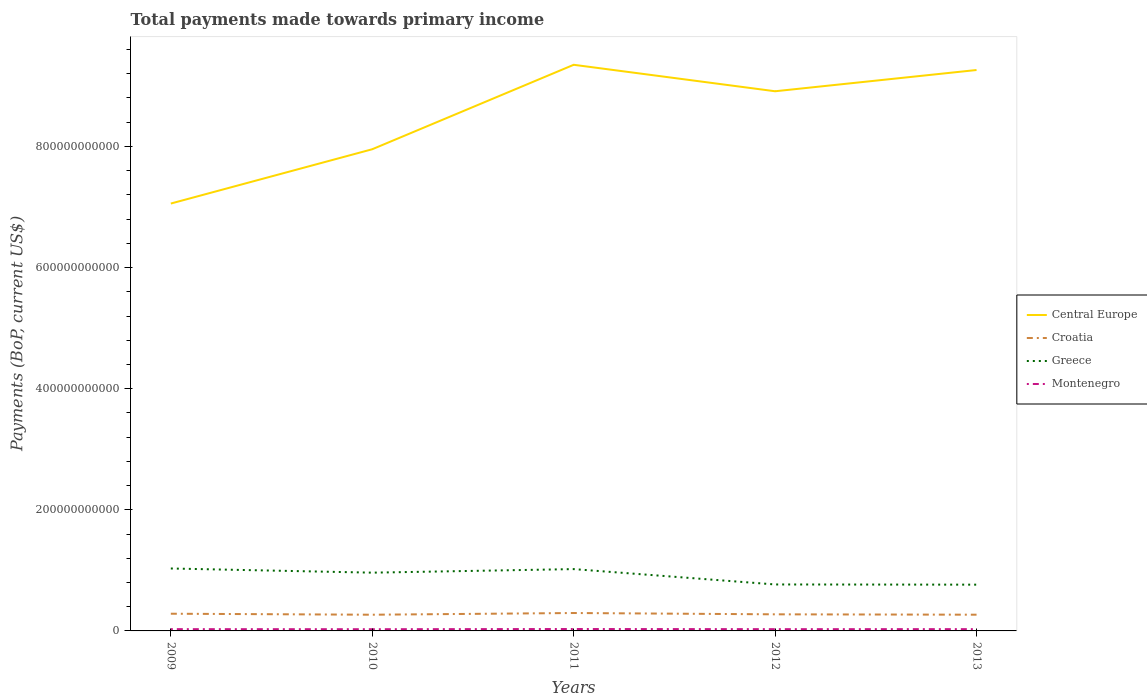How many different coloured lines are there?
Provide a succinct answer. 4. Is the number of lines equal to the number of legend labels?
Offer a very short reply. Yes. Across all years, what is the maximum total payments made towards primary income in Croatia?
Give a very brief answer. 2.67e+1. In which year was the total payments made towards primary income in Greece maximum?
Your answer should be compact. 2013. What is the total total payments made towards primary income in Greece in the graph?
Make the answer very short. 2.67e+1. What is the difference between the highest and the second highest total payments made towards primary income in Croatia?
Provide a succinct answer. 2.82e+09. How many years are there in the graph?
Ensure brevity in your answer.  5. What is the difference between two consecutive major ticks on the Y-axis?
Provide a succinct answer. 2.00e+11. Are the values on the major ticks of Y-axis written in scientific E-notation?
Give a very brief answer. No. Where does the legend appear in the graph?
Keep it short and to the point. Center right. How are the legend labels stacked?
Keep it short and to the point. Vertical. What is the title of the graph?
Your answer should be compact. Total payments made towards primary income. What is the label or title of the X-axis?
Ensure brevity in your answer.  Years. What is the label or title of the Y-axis?
Provide a short and direct response. Payments (BoP, current US$). What is the Payments (BoP, current US$) in Central Europe in 2009?
Provide a short and direct response. 7.06e+11. What is the Payments (BoP, current US$) of Croatia in 2009?
Ensure brevity in your answer.  2.84e+1. What is the Payments (BoP, current US$) in Greece in 2009?
Ensure brevity in your answer.  1.03e+11. What is the Payments (BoP, current US$) in Montenegro in 2009?
Provide a succinct answer. 2.93e+09. What is the Payments (BoP, current US$) of Central Europe in 2010?
Provide a succinct answer. 7.95e+11. What is the Payments (BoP, current US$) of Croatia in 2010?
Offer a terse response. 2.67e+1. What is the Payments (BoP, current US$) of Greece in 2010?
Your response must be concise. 9.62e+1. What is the Payments (BoP, current US$) of Montenegro in 2010?
Offer a terse response. 2.83e+09. What is the Payments (BoP, current US$) in Central Europe in 2011?
Keep it short and to the point. 9.35e+11. What is the Payments (BoP, current US$) in Croatia in 2011?
Offer a terse response. 2.96e+1. What is the Payments (BoP, current US$) of Greece in 2011?
Provide a short and direct response. 1.02e+11. What is the Payments (BoP, current US$) in Montenegro in 2011?
Provide a succinct answer. 3.15e+09. What is the Payments (BoP, current US$) of Central Europe in 2012?
Give a very brief answer. 8.91e+11. What is the Payments (BoP, current US$) in Croatia in 2012?
Your answer should be very brief. 2.74e+1. What is the Payments (BoP, current US$) in Greece in 2012?
Provide a succinct answer. 7.67e+1. What is the Payments (BoP, current US$) in Montenegro in 2012?
Your response must be concise. 2.92e+09. What is the Payments (BoP, current US$) of Central Europe in 2013?
Ensure brevity in your answer.  9.26e+11. What is the Payments (BoP, current US$) of Croatia in 2013?
Your answer should be compact. 2.68e+1. What is the Payments (BoP, current US$) of Greece in 2013?
Provide a succinct answer. 7.64e+1. What is the Payments (BoP, current US$) of Montenegro in 2013?
Keep it short and to the point. 2.94e+09. Across all years, what is the maximum Payments (BoP, current US$) of Central Europe?
Provide a succinct answer. 9.35e+11. Across all years, what is the maximum Payments (BoP, current US$) in Croatia?
Give a very brief answer. 2.96e+1. Across all years, what is the maximum Payments (BoP, current US$) of Greece?
Keep it short and to the point. 1.03e+11. Across all years, what is the maximum Payments (BoP, current US$) of Montenegro?
Keep it short and to the point. 3.15e+09. Across all years, what is the minimum Payments (BoP, current US$) in Central Europe?
Offer a very short reply. 7.06e+11. Across all years, what is the minimum Payments (BoP, current US$) of Croatia?
Offer a very short reply. 2.67e+1. Across all years, what is the minimum Payments (BoP, current US$) of Greece?
Your response must be concise. 7.64e+1. Across all years, what is the minimum Payments (BoP, current US$) of Montenegro?
Provide a short and direct response. 2.83e+09. What is the total Payments (BoP, current US$) of Central Europe in the graph?
Provide a short and direct response. 4.25e+12. What is the total Payments (BoP, current US$) of Croatia in the graph?
Your answer should be compact. 1.39e+11. What is the total Payments (BoP, current US$) of Greece in the graph?
Your answer should be very brief. 4.54e+11. What is the total Payments (BoP, current US$) in Montenegro in the graph?
Keep it short and to the point. 1.48e+1. What is the difference between the Payments (BoP, current US$) in Central Europe in 2009 and that in 2010?
Your answer should be very brief. -8.97e+1. What is the difference between the Payments (BoP, current US$) of Croatia in 2009 and that in 2010?
Your response must be concise. 1.66e+09. What is the difference between the Payments (BoP, current US$) of Greece in 2009 and that in 2010?
Give a very brief answer. 6.88e+09. What is the difference between the Payments (BoP, current US$) in Montenegro in 2009 and that in 2010?
Offer a terse response. 1.07e+08. What is the difference between the Payments (BoP, current US$) in Central Europe in 2009 and that in 2011?
Offer a terse response. -2.29e+11. What is the difference between the Payments (BoP, current US$) in Croatia in 2009 and that in 2011?
Your response must be concise. -1.16e+09. What is the difference between the Payments (BoP, current US$) of Greece in 2009 and that in 2011?
Your answer should be very brief. 1.01e+09. What is the difference between the Payments (BoP, current US$) of Montenegro in 2009 and that in 2011?
Your answer should be very brief. -2.19e+08. What is the difference between the Payments (BoP, current US$) in Central Europe in 2009 and that in 2012?
Your response must be concise. -1.85e+11. What is the difference between the Payments (BoP, current US$) of Croatia in 2009 and that in 2012?
Your answer should be compact. 1.01e+09. What is the difference between the Payments (BoP, current US$) of Greece in 2009 and that in 2012?
Provide a short and direct response. 2.64e+1. What is the difference between the Payments (BoP, current US$) of Montenegro in 2009 and that in 2012?
Your answer should be compact. 1.51e+07. What is the difference between the Payments (BoP, current US$) in Central Europe in 2009 and that in 2013?
Your response must be concise. -2.20e+11. What is the difference between the Payments (BoP, current US$) in Croatia in 2009 and that in 2013?
Provide a short and direct response. 1.62e+09. What is the difference between the Payments (BoP, current US$) of Greece in 2009 and that in 2013?
Your answer should be very brief. 2.67e+1. What is the difference between the Payments (BoP, current US$) of Montenegro in 2009 and that in 2013?
Give a very brief answer. -4.58e+06. What is the difference between the Payments (BoP, current US$) in Central Europe in 2010 and that in 2011?
Keep it short and to the point. -1.39e+11. What is the difference between the Payments (BoP, current US$) of Croatia in 2010 and that in 2011?
Offer a very short reply. -2.82e+09. What is the difference between the Payments (BoP, current US$) of Greece in 2010 and that in 2011?
Offer a terse response. -5.87e+09. What is the difference between the Payments (BoP, current US$) in Montenegro in 2010 and that in 2011?
Make the answer very short. -3.26e+08. What is the difference between the Payments (BoP, current US$) of Central Europe in 2010 and that in 2012?
Your answer should be compact. -9.57e+1. What is the difference between the Payments (BoP, current US$) in Croatia in 2010 and that in 2012?
Make the answer very short. -6.53e+08. What is the difference between the Payments (BoP, current US$) of Greece in 2010 and that in 2012?
Ensure brevity in your answer.  1.95e+1. What is the difference between the Payments (BoP, current US$) in Montenegro in 2010 and that in 2012?
Ensure brevity in your answer.  -9.16e+07. What is the difference between the Payments (BoP, current US$) of Central Europe in 2010 and that in 2013?
Provide a short and direct response. -1.31e+11. What is the difference between the Payments (BoP, current US$) of Croatia in 2010 and that in 2013?
Make the answer very short. -4.69e+07. What is the difference between the Payments (BoP, current US$) in Greece in 2010 and that in 2013?
Provide a short and direct response. 1.98e+1. What is the difference between the Payments (BoP, current US$) in Montenegro in 2010 and that in 2013?
Keep it short and to the point. -1.11e+08. What is the difference between the Payments (BoP, current US$) in Central Europe in 2011 and that in 2012?
Make the answer very short. 4.37e+1. What is the difference between the Payments (BoP, current US$) of Croatia in 2011 and that in 2012?
Your answer should be compact. 2.17e+09. What is the difference between the Payments (BoP, current US$) of Greece in 2011 and that in 2012?
Give a very brief answer. 2.54e+1. What is the difference between the Payments (BoP, current US$) in Montenegro in 2011 and that in 2012?
Your answer should be compact. 2.34e+08. What is the difference between the Payments (BoP, current US$) in Central Europe in 2011 and that in 2013?
Make the answer very short. 8.61e+09. What is the difference between the Payments (BoP, current US$) in Croatia in 2011 and that in 2013?
Offer a very short reply. 2.77e+09. What is the difference between the Payments (BoP, current US$) of Greece in 2011 and that in 2013?
Provide a short and direct response. 2.57e+1. What is the difference between the Payments (BoP, current US$) of Montenegro in 2011 and that in 2013?
Provide a short and direct response. 2.14e+08. What is the difference between the Payments (BoP, current US$) of Central Europe in 2012 and that in 2013?
Make the answer very short. -3.51e+1. What is the difference between the Payments (BoP, current US$) in Croatia in 2012 and that in 2013?
Offer a terse response. 6.06e+08. What is the difference between the Payments (BoP, current US$) in Greece in 2012 and that in 2013?
Offer a terse response. 3.26e+08. What is the difference between the Payments (BoP, current US$) in Montenegro in 2012 and that in 2013?
Your answer should be compact. -1.97e+07. What is the difference between the Payments (BoP, current US$) of Central Europe in 2009 and the Payments (BoP, current US$) of Croatia in 2010?
Offer a terse response. 6.79e+11. What is the difference between the Payments (BoP, current US$) of Central Europe in 2009 and the Payments (BoP, current US$) of Greece in 2010?
Your answer should be very brief. 6.10e+11. What is the difference between the Payments (BoP, current US$) of Central Europe in 2009 and the Payments (BoP, current US$) of Montenegro in 2010?
Provide a succinct answer. 7.03e+11. What is the difference between the Payments (BoP, current US$) of Croatia in 2009 and the Payments (BoP, current US$) of Greece in 2010?
Keep it short and to the point. -6.78e+1. What is the difference between the Payments (BoP, current US$) of Croatia in 2009 and the Payments (BoP, current US$) of Montenegro in 2010?
Your answer should be compact. 2.56e+1. What is the difference between the Payments (BoP, current US$) in Greece in 2009 and the Payments (BoP, current US$) in Montenegro in 2010?
Make the answer very short. 1.00e+11. What is the difference between the Payments (BoP, current US$) in Central Europe in 2009 and the Payments (BoP, current US$) in Croatia in 2011?
Provide a short and direct response. 6.76e+11. What is the difference between the Payments (BoP, current US$) of Central Europe in 2009 and the Payments (BoP, current US$) of Greece in 2011?
Make the answer very short. 6.04e+11. What is the difference between the Payments (BoP, current US$) in Central Europe in 2009 and the Payments (BoP, current US$) in Montenegro in 2011?
Offer a terse response. 7.03e+11. What is the difference between the Payments (BoP, current US$) of Croatia in 2009 and the Payments (BoP, current US$) of Greece in 2011?
Keep it short and to the point. -7.37e+1. What is the difference between the Payments (BoP, current US$) of Croatia in 2009 and the Payments (BoP, current US$) of Montenegro in 2011?
Your answer should be compact. 2.53e+1. What is the difference between the Payments (BoP, current US$) of Greece in 2009 and the Payments (BoP, current US$) of Montenegro in 2011?
Offer a very short reply. 9.99e+1. What is the difference between the Payments (BoP, current US$) in Central Europe in 2009 and the Payments (BoP, current US$) in Croatia in 2012?
Your answer should be compact. 6.78e+11. What is the difference between the Payments (BoP, current US$) in Central Europe in 2009 and the Payments (BoP, current US$) in Greece in 2012?
Give a very brief answer. 6.29e+11. What is the difference between the Payments (BoP, current US$) in Central Europe in 2009 and the Payments (BoP, current US$) in Montenegro in 2012?
Your response must be concise. 7.03e+11. What is the difference between the Payments (BoP, current US$) of Croatia in 2009 and the Payments (BoP, current US$) of Greece in 2012?
Keep it short and to the point. -4.83e+1. What is the difference between the Payments (BoP, current US$) in Croatia in 2009 and the Payments (BoP, current US$) in Montenegro in 2012?
Make the answer very short. 2.55e+1. What is the difference between the Payments (BoP, current US$) of Greece in 2009 and the Payments (BoP, current US$) of Montenegro in 2012?
Make the answer very short. 1.00e+11. What is the difference between the Payments (BoP, current US$) in Central Europe in 2009 and the Payments (BoP, current US$) in Croatia in 2013?
Offer a very short reply. 6.79e+11. What is the difference between the Payments (BoP, current US$) of Central Europe in 2009 and the Payments (BoP, current US$) of Greece in 2013?
Ensure brevity in your answer.  6.29e+11. What is the difference between the Payments (BoP, current US$) in Central Europe in 2009 and the Payments (BoP, current US$) in Montenegro in 2013?
Offer a terse response. 7.03e+11. What is the difference between the Payments (BoP, current US$) in Croatia in 2009 and the Payments (BoP, current US$) in Greece in 2013?
Keep it short and to the point. -4.80e+1. What is the difference between the Payments (BoP, current US$) of Croatia in 2009 and the Payments (BoP, current US$) of Montenegro in 2013?
Ensure brevity in your answer.  2.55e+1. What is the difference between the Payments (BoP, current US$) in Greece in 2009 and the Payments (BoP, current US$) in Montenegro in 2013?
Give a very brief answer. 1.00e+11. What is the difference between the Payments (BoP, current US$) in Central Europe in 2010 and the Payments (BoP, current US$) in Croatia in 2011?
Your response must be concise. 7.66e+11. What is the difference between the Payments (BoP, current US$) in Central Europe in 2010 and the Payments (BoP, current US$) in Greece in 2011?
Offer a terse response. 6.93e+11. What is the difference between the Payments (BoP, current US$) of Central Europe in 2010 and the Payments (BoP, current US$) of Montenegro in 2011?
Ensure brevity in your answer.  7.92e+11. What is the difference between the Payments (BoP, current US$) in Croatia in 2010 and the Payments (BoP, current US$) in Greece in 2011?
Give a very brief answer. -7.53e+1. What is the difference between the Payments (BoP, current US$) in Croatia in 2010 and the Payments (BoP, current US$) in Montenegro in 2011?
Ensure brevity in your answer.  2.36e+1. What is the difference between the Payments (BoP, current US$) of Greece in 2010 and the Payments (BoP, current US$) of Montenegro in 2011?
Offer a terse response. 9.31e+1. What is the difference between the Payments (BoP, current US$) in Central Europe in 2010 and the Payments (BoP, current US$) in Croatia in 2012?
Offer a very short reply. 7.68e+11. What is the difference between the Payments (BoP, current US$) of Central Europe in 2010 and the Payments (BoP, current US$) of Greece in 2012?
Give a very brief answer. 7.19e+11. What is the difference between the Payments (BoP, current US$) of Central Europe in 2010 and the Payments (BoP, current US$) of Montenegro in 2012?
Offer a very short reply. 7.92e+11. What is the difference between the Payments (BoP, current US$) of Croatia in 2010 and the Payments (BoP, current US$) of Greece in 2012?
Keep it short and to the point. -5.00e+1. What is the difference between the Payments (BoP, current US$) of Croatia in 2010 and the Payments (BoP, current US$) of Montenegro in 2012?
Your answer should be very brief. 2.38e+1. What is the difference between the Payments (BoP, current US$) of Greece in 2010 and the Payments (BoP, current US$) of Montenegro in 2012?
Your response must be concise. 9.33e+1. What is the difference between the Payments (BoP, current US$) in Central Europe in 2010 and the Payments (BoP, current US$) in Croatia in 2013?
Your answer should be compact. 7.69e+11. What is the difference between the Payments (BoP, current US$) of Central Europe in 2010 and the Payments (BoP, current US$) of Greece in 2013?
Keep it short and to the point. 7.19e+11. What is the difference between the Payments (BoP, current US$) of Central Europe in 2010 and the Payments (BoP, current US$) of Montenegro in 2013?
Your response must be concise. 7.92e+11. What is the difference between the Payments (BoP, current US$) of Croatia in 2010 and the Payments (BoP, current US$) of Greece in 2013?
Your answer should be very brief. -4.96e+1. What is the difference between the Payments (BoP, current US$) of Croatia in 2010 and the Payments (BoP, current US$) of Montenegro in 2013?
Your answer should be very brief. 2.38e+1. What is the difference between the Payments (BoP, current US$) of Greece in 2010 and the Payments (BoP, current US$) of Montenegro in 2013?
Your answer should be very brief. 9.33e+1. What is the difference between the Payments (BoP, current US$) in Central Europe in 2011 and the Payments (BoP, current US$) in Croatia in 2012?
Your response must be concise. 9.07e+11. What is the difference between the Payments (BoP, current US$) of Central Europe in 2011 and the Payments (BoP, current US$) of Greece in 2012?
Keep it short and to the point. 8.58e+11. What is the difference between the Payments (BoP, current US$) in Central Europe in 2011 and the Payments (BoP, current US$) in Montenegro in 2012?
Ensure brevity in your answer.  9.32e+11. What is the difference between the Payments (BoP, current US$) in Croatia in 2011 and the Payments (BoP, current US$) in Greece in 2012?
Offer a very short reply. -4.71e+1. What is the difference between the Payments (BoP, current US$) of Croatia in 2011 and the Payments (BoP, current US$) of Montenegro in 2012?
Provide a short and direct response. 2.67e+1. What is the difference between the Payments (BoP, current US$) of Greece in 2011 and the Payments (BoP, current US$) of Montenegro in 2012?
Offer a very short reply. 9.92e+1. What is the difference between the Payments (BoP, current US$) in Central Europe in 2011 and the Payments (BoP, current US$) in Croatia in 2013?
Provide a succinct answer. 9.08e+11. What is the difference between the Payments (BoP, current US$) of Central Europe in 2011 and the Payments (BoP, current US$) of Greece in 2013?
Provide a succinct answer. 8.58e+11. What is the difference between the Payments (BoP, current US$) in Central Europe in 2011 and the Payments (BoP, current US$) in Montenegro in 2013?
Your response must be concise. 9.32e+11. What is the difference between the Payments (BoP, current US$) in Croatia in 2011 and the Payments (BoP, current US$) in Greece in 2013?
Your answer should be compact. -4.68e+1. What is the difference between the Payments (BoP, current US$) of Croatia in 2011 and the Payments (BoP, current US$) of Montenegro in 2013?
Give a very brief answer. 2.66e+1. What is the difference between the Payments (BoP, current US$) of Greece in 2011 and the Payments (BoP, current US$) of Montenegro in 2013?
Your answer should be very brief. 9.91e+1. What is the difference between the Payments (BoP, current US$) of Central Europe in 2012 and the Payments (BoP, current US$) of Croatia in 2013?
Your answer should be compact. 8.64e+11. What is the difference between the Payments (BoP, current US$) of Central Europe in 2012 and the Payments (BoP, current US$) of Greece in 2013?
Offer a terse response. 8.15e+11. What is the difference between the Payments (BoP, current US$) in Central Europe in 2012 and the Payments (BoP, current US$) in Montenegro in 2013?
Offer a terse response. 8.88e+11. What is the difference between the Payments (BoP, current US$) of Croatia in 2012 and the Payments (BoP, current US$) of Greece in 2013?
Ensure brevity in your answer.  -4.90e+1. What is the difference between the Payments (BoP, current US$) in Croatia in 2012 and the Payments (BoP, current US$) in Montenegro in 2013?
Provide a short and direct response. 2.45e+1. What is the difference between the Payments (BoP, current US$) of Greece in 2012 and the Payments (BoP, current US$) of Montenegro in 2013?
Provide a short and direct response. 7.38e+1. What is the average Payments (BoP, current US$) of Central Europe per year?
Your response must be concise. 8.51e+11. What is the average Payments (BoP, current US$) in Croatia per year?
Give a very brief answer. 2.78e+1. What is the average Payments (BoP, current US$) of Greece per year?
Your response must be concise. 9.09e+1. What is the average Payments (BoP, current US$) of Montenegro per year?
Give a very brief answer. 2.95e+09. In the year 2009, what is the difference between the Payments (BoP, current US$) in Central Europe and Payments (BoP, current US$) in Croatia?
Offer a very short reply. 6.77e+11. In the year 2009, what is the difference between the Payments (BoP, current US$) in Central Europe and Payments (BoP, current US$) in Greece?
Your response must be concise. 6.03e+11. In the year 2009, what is the difference between the Payments (BoP, current US$) in Central Europe and Payments (BoP, current US$) in Montenegro?
Give a very brief answer. 7.03e+11. In the year 2009, what is the difference between the Payments (BoP, current US$) in Croatia and Payments (BoP, current US$) in Greece?
Offer a terse response. -7.47e+1. In the year 2009, what is the difference between the Payments (BoP, current US$) in Croatia and Payments (BoP, current US$) in Montenegro?
Offer a very short reply. 2.55e+1. In the year 2009, what is the difference between the Payments (BoP, current US$) of Greece and Payments (BoP, current US$) of Montenegro?
Give a very brief answer. 1.00e+11. In the year 2010, what is the difference between the Payments (BoP, current US$) of Central Europe and Payments (BoP, current US$) of Croatia?
Your answer should be very brief. 7.69e+11. In the year 2010, what is the difference between the Payments (BoP, current US$) of Central Europe and Payments (BoP, current US$) of Greece?
Keep it short and to the point. 6.99e+11. In the year 2010, what is the difference between the Payments (BoP, current US$) in Central Europe and Payments (BoP, current US$) in Montenegro?
Your answer should be very brief. 7.93e+11. In the year 2010, what is the difference between the Payments (BoP, current US$) of Croatia and Payments (BoP, current US$) of Greece?
Offer a very short reply. -6.95e+1. In the year 2010, what is the difference between the Payments (BoP, current US$) in Croatia and Payments (BoP, current US$) in Montenegro?
Offer a terse response. 2.39e+1. In the year 2010, what is the difference between the Payments (BoP, current US$) of Greece and Payments (BoP, current US$) of Montenegro?
Offer a terse response. 9.34e+1. In the year 2011, what is the difference between the Payments (BoP, current US$) of Central Europe and Payments (BoP, current US$) of Croatia?
Your response must be concise. 9.05e+11. In the year 2011, what is the difference between the Payments (BoP, current US$) in Central Europe and Payments (BoP, current US$) in Greece?
Give a very brief answer. 8.33e+11. In the year 2011, what is the difference between the Payments (BoP, current US$) of Central Europe and Payments (BoP, current US$) of Montenegro?
Your answer should be compact. 9.32e+11. In the year 2011, what is the difference between the Payments (BoP, current US$) of Croatia and Payments (BoP, current US$) of Greece?
Your response must be concise. -7.25e+1. In the year 2011, what is the difference between the Payments (BoP, current US$) of Croatia and Payments (BoP, current US$) of Montenegro?
Offer a very short reply. 2.64e+1. In the year 2011, what is the difference between the Payments (BoP, current US$) of Greece and Payments (BoP, current US$) of Montenegro?
Your answer should be compact. 9.89e+1. In the year 2012, what is the difference between the Payments (BoP, current US$) in Central Europe and Payments (BoP, current US$) in Croatia?
Make the answer very short. 8.64e+11. In the year 2012, what is the difference between the Payments (BoP, current US$) in Central Europe and Payments (BoP, current US$) in Greece?
Keep it short and to the point. 8.14e+11. In the year 2012, what is the difference between the Payments (BoP, current US$) in Central Europe and Payments (BoP, current US$) in Montenegro?
Offer a terse response. 8.88e+11. In the year 2012, what is the difference between the Payments (BoP, current US$) in Croatia and Payments (BoP, current US$) in Greece?
Your response must be concise. -4.93e+1. In the year 2012, what is the difference between the Payments (BoP, current US$) of Croatia and Payments (BoP, current US$) of Montenegro?
Your response must be concise. 2.45e+1. In the year 2012, what is the difference between the Payments (BoP, current US$) in Greece and Payments (BoP, current US$) in Montenegro?
Provide a short and direct response. 7.38e+1. In the year 2013, what is the difference between the Payments (BoP, current US$) in Central Europe and Payments (BoP, current US$) in Croatia?
Keep it short and to the point. 8.99e+11. In the year 2013, what is the difference between the Payments (BoP, current US$) of Central Europe and Payments (BoP, current US$) of Greece?
Make the answer very short. 8.50e+11. In the year 2013, what is the difference between the Payments (BoP, current US$) of Central Europe and Payments (BoP, current US$) of Montenegro?
Offer a terse response. 9.23e+11. In the year 2013, what is the difference between the Payments (BoP, current US$) in Croatia and Payments (BoP, current US$) in Greece?
Give a very brief answer. -4.96e+1. In the year 2013, what is the difference between the Payments (BoP, current US$) of Croatia and Payments (BoP, current US$) of Montenegro?
Make the answer very short. 2.39e+1. In the year 2013, what is the difference between the Payments (BoP, current US$) in Greece and Payments (BoP, current US$) in Montenegro?
Ensure brevity in your answer.  7.35e+1. What is the ratio of the Payments (BoP, current US$) of Central Europe in 2009 to that in 2010?
Your answer should be compact. 0.89. What is the ratio of the Payments (BoP, current US$) of Croatia in 2009 to that in 2010?
Give a very brief answer. 1.06. What is the ratio of the Payments (BoP, current US$) of Greece in 2009 to that in 2010?
Provide a short and direct response. 1.07. What is the ratio of the Payments (BoP, current US$) of Montenegro in 2009 to that in 2010?
Offer a very short reply. 1.04. What is the ratio of the Payments (BoP, current US$) of Central Europe in 2009 to that in 2011?
Give a very brief answer. 0.75. What is the ratio of the Payments (BoP, current US$) of Croatia in 2009 to that in 2011?
Offer a terse response. 0.96. What is the ratio of the Payments (BoP, current US$) of Greece in 2009 to that in 2011?
Your answer should be compact. 1.01. What is the ratio of the Payments (BoP, current US$) in Montenegro in 2009 to that in 2011?
Your response must be concise. 0.93. What is the ratio of the Payments (BoP, current US$) in Central Europe in 2009 to that in 2012?
Your response must be concise. 0.79. What is the ratio of the Payments (BoP, current US$) of Croatia in 2009 to that in 2012?
Ensure brevity in your answer.  1.04. What is the ratio of the Payments (BoP, current US$) of Greece in 2009 to that in 2012?
Offer a terse response. 1.34. What is the ratio of the Payments (BoP, current US$) of Central Europe in 2009 to that in 2013?
Provide a succinct answer. 0.76. What is the ratio of the Payments (BoP, current US$) of Croatia in 2009 to that in 2013?
Give a very brief answer. 1.06. What is the ratio of the Payments (BoP, current US$) in Greece in 2009 to that in 2013?
Ensure brevity in your answer.  1.35. What is the ratio of the Payments (BoP, current US$) in Central Europe in 2010 to that in 2011?
Keep it short and to the point. 0.85. What is the ratio of the Payments (BoP, current US$) in Croatia in 2010 to that in 2011?
Your answer should be compact. 0.9. What is the ratio of the Payments (BoP, current US$) in Greece in 2010 to that in 2011?
Offer a very short reply. 0.94. What is the ratio of the Payments (BoP, current US$) of Montenegro in 2010 to that in 2011?
Offer a terse response. 0.9. What is the ratio of the Payments (BoP, current US$) in Central Europe in 2010 to that in 2012?
Give a very brief answer. 0.89. What is the ratio of the Payments (BoP, current US$) of Croatia in 2010 to that in 2012?
Ensure brevity in your answer.  0.98. What is the ratio of the Payments (BoP, current US$) in Greece in 2010 to that in 2012?
Your answer should be very brief. 1.25. What is the ratio of the Payments (BoP, current US$) of Montenegro in 2010 to that in 2012?
Give a very brief answer. 0.97. What is the ratio of the Payments (BoP, current US$) in Central Europe in 2010 to that in 2013?
Keep it short and to the point. 0.86. What is the ratio of the Payments (BoP, current US$) of Croatia in 2010 to that in 2013?
Your answer should be very brief. 1. What is the ratio of the Payments (BoP, current US$) of Greece in 2010 to that in 2013?
Give a very brief answer. 1.26. What is the ratio of the Payments (BoP, current US$) in Montenegro in 2010 to that in 2013?
Ensure brevity in your answer.  0.96. What is the ratio of the Payments (BoP, current US$) of Central Europe in 2011 to that in 2012?
Provide a short and direct response. 1.05. What is the ratio of the Payments (BoP, current US$) in Croatia in 2011 to that in 2012?
Provide a succinct answer. 1.08. What is the ratio of the Payments (BoP, current US$) of Greece in 2011 to that in 2012?
Your answer should be very brief. 1.33. What is the ratio of the Payments (BoP, current US$) of Montenegro in 2011 to that in 2012?
Offer a terse response. 1.08. What is the ratio of the Payments (BoP, current US$) in Central Europe in 2011 to that in 2013?
Provide a succinct answer. 1.01. What is the ratio of the Payments (BoP, current US$) in Croatia in 2011 to that in 2013?
Make the answer very short. 1.1. What is the ratio of the Payments (BoP, current US$) in Greece in 2011 to that in 2013?
Ensure brevity in your answer.  1.34. What is the ratio of the Payments (BoP, current US$) in Montenegro in 2011 to that in 2013?
Offer a very short reply. 1.07. What is the ratio of the Payments (BoP, current US$) of Central Europe in 2012 to that in 2013?
Keep it short and to the point. 0.96. What is the ratio of the Payments (BoP, current US$) of Croatia in 2012 to that in 2013?
Offer a very short reply. 1.02. What is the ratio of the Payments (BoP, current US$) in Greece in 2012 to that in 2013?
Ensure brevity in your answer.  1. What is the ratio of the Payments (BoP, current US$) of Montenegro in 2012 to that in 2013?
Give a very brief answer. 0.99. What is the difference between the highest and the second highest Payments (BoP, current US$) of Central Europe?
Provide a short and direct response. 8.61e+09. What is the difference between the highest and the second highest Payments (BoP, current US$) in Croatia?
Offer a very short reply. 1.16e+09. What is the difference between the highest and the second highest Payments (BoP, current US$) in Greece?
Keep it short and to the point. 1.01e+09. What is the difference between the highest and the second highest Payments (BoP, current US$) in Montenegro?
Keep it short and to the point. 2.14e+08. What is the difference between the highest and the lowest Payments (BoP, current US$) in Central Europe?
Your answer should be very brief. 2.29e+11. What is the difference between the highest and the lowest Payments (BoP, current US$) of Croatia?
Offer a very short reply. 2.82e+09. What is the difference between the highest and the lowest Payments (BoP, current US$) of Greece?
Offer a very short reply. 2.67e+1. What is the difference between the highest and the lowest Payments (BoP, current US$) in Montenegro?
Provide a short and direct response. 3.26e+08. 